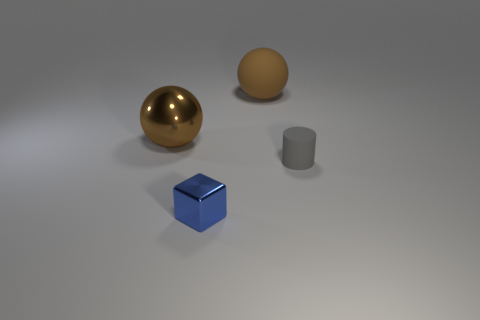The object that is behind the cylinder and to the right of the large brown shiny ball has what shape?
Your answer should be compact. Sphere. How many brown matte cubes are there?
Keep it short and to the point. 0. The object that is the same color as the big matte sphere is what shape?
Offer a very short reply. Sphere. There is another thing that is the same shape as the brown matte thing; what is its size?
Your answer should be very brief. Large. Is the shape of the tiny thing that is behind the metallic block the same as  the small blue metallic thing?
Offer a terse response. No. What color is the block that is left of the rubber sphere?
Your answer should be compact. Blue. How many other things are there of the same size as the blue metal thing?
Give a very brief answer. 1. Are there any other things that are the same shape as the brown metallic thing?
Keep it short and to the point. Yes. Are there an equal number of large brown rubber things in front of the big metallic sphere and big balls?
Your response must be concise. No. How many brown things have the same material as the gray object?
Provide a short and direct response. 1. 